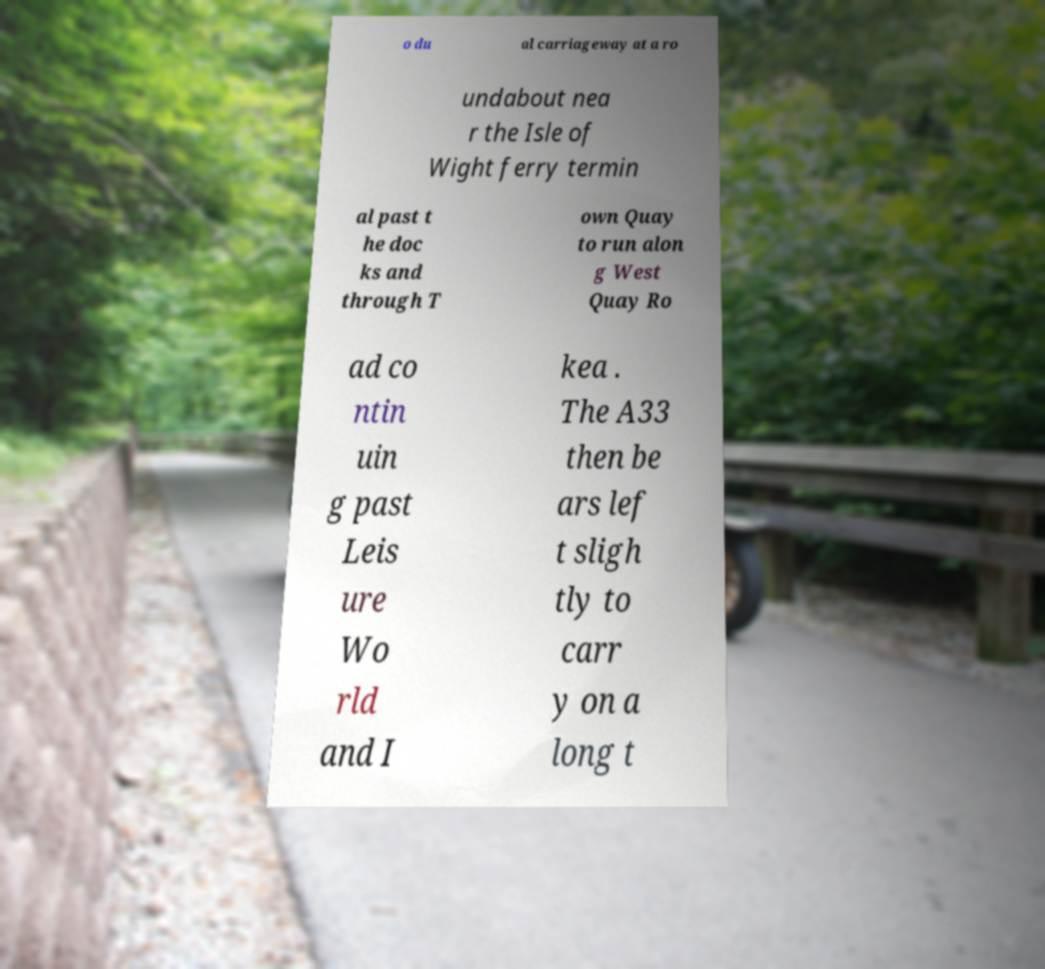Can you read and provide the text displayed in the image?This photo seems to have some interesting text. Can you extract and type it out for me? o du al carriageway at a ro undabout nea r the Isle of Wight ferry termin al past t he doc ks and through T own Quay to run alon g West Quay Ro ad co ntin uin g past Leis ure Wo rld and I kea . The A33 then be ars lef t sligh tly to carr y on a long t 